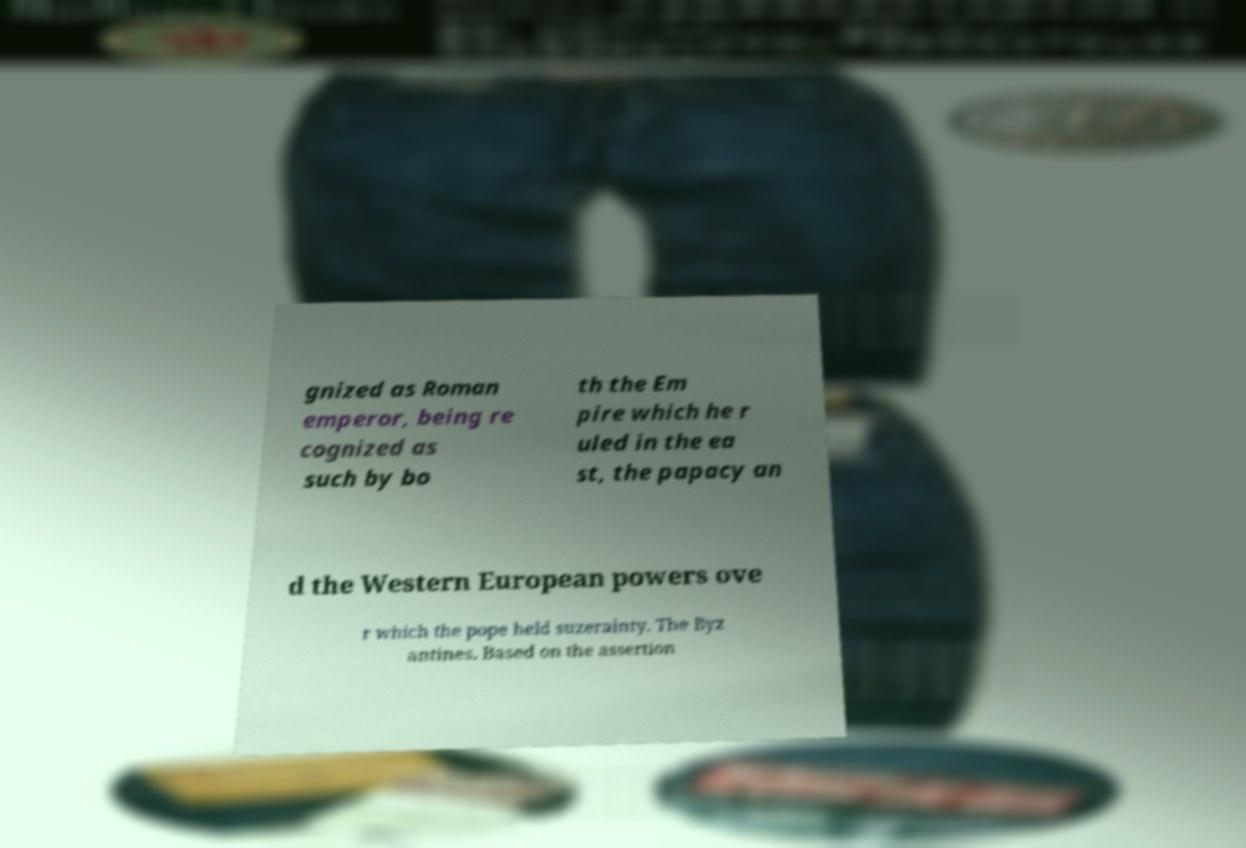What messages or text are displayed in this image? I need them in a readable, typed format. gnized as Roman emperor, being re cognized as such by bo th the Em pire which he r uled in the ea st, the papacy an d the Western European powers ove r which the pope held suzerainty. The Byz antines. Based on the assertion 